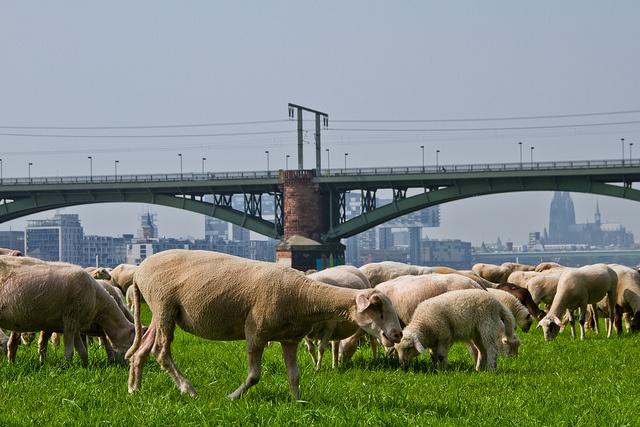Describe the objects in this image and their specific colors. I can see sheep in darkgray, black, olive, and tan tones, sheep in darkgray, black, darkgreen, and gray tones, sheep in darkgray, darkgreen, black, and gray tones, sheep in darkgray, black, darkgreen, gray, and tan tones, and sheep in darkgray, black, darkgreen, lightgray, and gray tones in this image. 